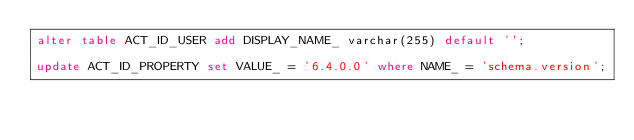Convert code to text. <code><loc_0><loc_0><loc_500><loc_500><_SQL_>alter table ACT_ID_USER add DISPLAY_NAME_ varchar(255) default '';

update ACT_ID_PROPERTY set VALUE_ = '6.4.0.0' where NAME_ = 'schema.version';
</code> 